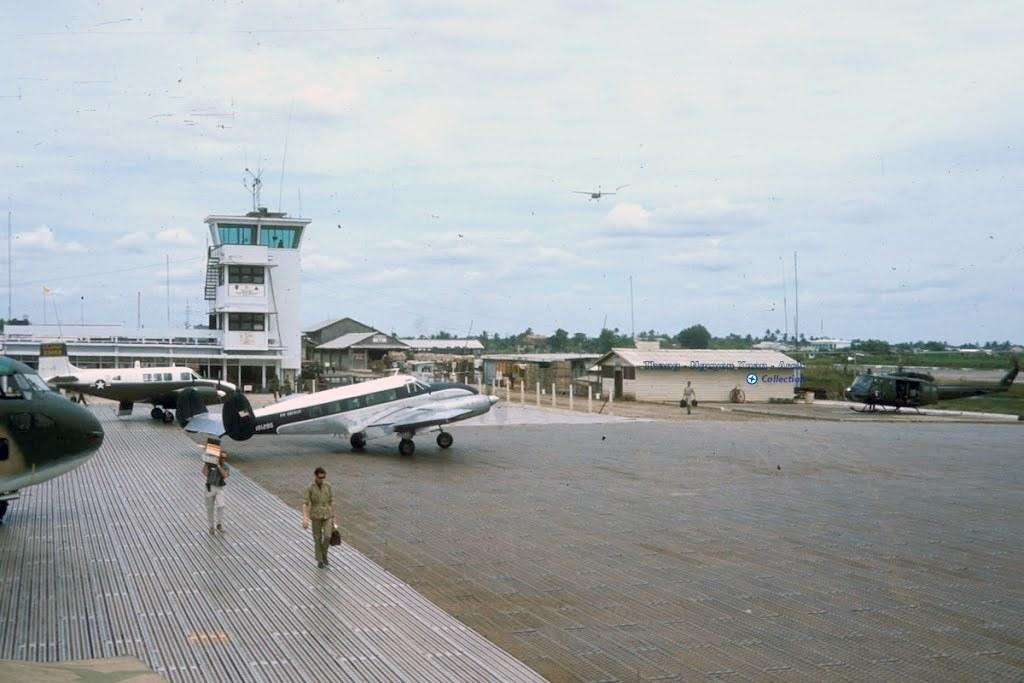What are the people in the image doing? The people in the image are walking. What can be seen in the background of the image? There are airplanes in the background of the image. What type of structures are present in the image? There are buildings in the image. What other objects can be seen in the image? There are poles and trees in the image. What is the condition of the sky in the image? The sky is clear in the image. What type of vegetable is being harvested by the goat in the image? There is no goat or vegetable present in the image. What kind of trouble are the people in the image facing? There is no indication of trouble or any problems faced by the people in the image. 